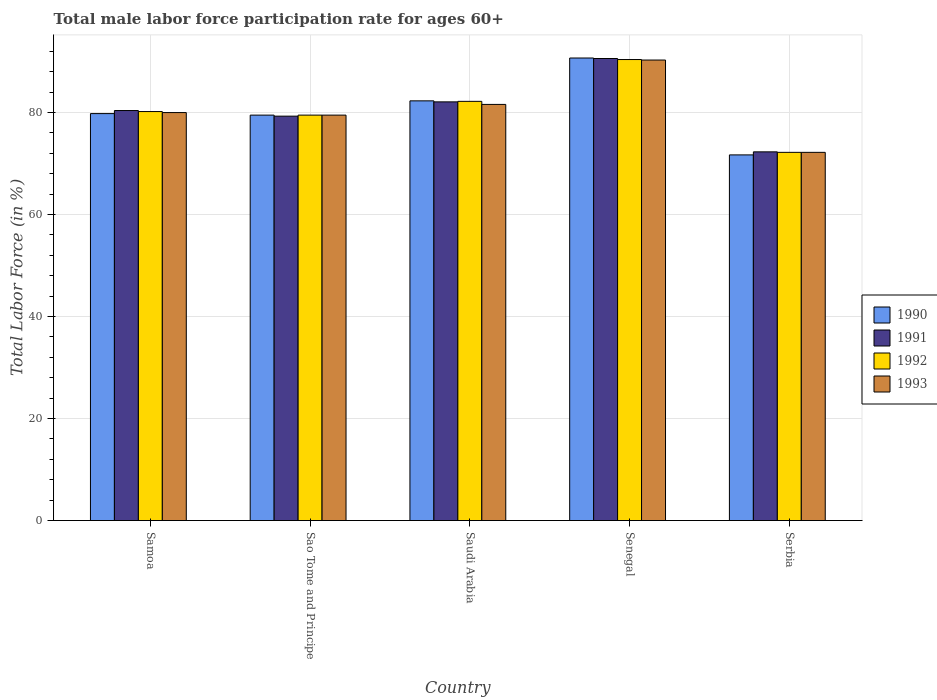How many groups of bars are there?
Ensure brevity in your answer.  5. Are the number of bars per tick equal to the number of legend labels?
Provide a succinct answer. Yes. How many bars are there on the 3rd tick from the left?
Provide a short and direct response. 4. How many bars are there on the 1st tick from the right?
Make the answer very short. 4. What is the label of the 5th group of bars from the left?
Give a very brief answer. Serbia. In how many cases, is the number of bars for a given country not equal to the number of legend labels?
Your response must be concise. 0. What is the male labor force participation rate in 1991 in Sao Tome and Principe?
Give a very brief answer. 79.3. Across all countries, what is the maximum male labor force participation rate in 1991?
Offer a terse response. 90.6. Across all countries, what is the minimum male labor force participation rate in 1992?
Give a very brief answer. 72.2. In which country was the male labor force participation rate in 1993 maximum?
Offer a very short reply. Senegal. In which country was the male labor force participation rate in 1991 minimum?
Your answer should be very brief. Serbia. What is the total male labor force participation rate in 1991 in the graph?
Give a very brief answer. 404.7. What is the difference between the male labor force participation rate in 1992 in Saudi Arabia and that in Senegal?
Offer a terse response. -8.2. What is the difference between the male labor force participation rate in 1993 in Sao Tome and Principe and the male labor force participation rate in 1990 in Senegal?
Keep it short and to the point. -11.2. What is the average male labor force participation rate in 1992 per country?
Keep it short and to the point. 80.9. What is the difference between the male labor force participation rate of/in 1990 and male labor force participation rate of/in 1992 in Samoa?
Provide a short and direct response. -0.4. What is the ratio of the male labor force participation rate in 1990 in Sao Tome and Principe to that in Saudi Arabia?
Offer a very short reply. 0.97. Is the male labor force participation rate in 1990 in Sao Tome and Principe less than that in Serbia?
Give a very brief answer. No. What is the difference between the highest and the second highest male labor force participation rate in 1993?
Your answer should be very brief. -1.6. What is the difference between the highest and the lowest male labor force participation rate in 1991?
Provide a short and direct response. 18.3. In how many countries, is the male labor force participation rate in 1992 greater than the average male labor force participation rate in 1992 taken over all countries?
Give a very brief answer. 2. What does the 4th bar from the left in Serbia represents?
Your answer should be compact. 1993. Is it the case that in every country, the sum of the male labor force participation rate in 1991 and male labor force participation rate in 1990 is greater than the male labor force participation rate in 1993?
Offer a terse response. Yes. How many bars are there?
Make the answer very short. 20. Where does the legend appear in the graph?
Provide a succinct answer. Center right. How are the legend labels stacked?
Give a very brief answer. Vertical. What is the title of the graph?
Your answer should be compact. Total male labor force participation rate for ages 60+. What is the label or title of the X-axis?
Your response must be concise. Country. What is the label or title of the Y-axis?
Ensure brevity in your answer.  Total Labor Force (in %). What is the Total Labor Force (in %) of 1990 in Samoa?
Give a very brief answer. 79.8. What is the Total Labor Force (in %) in 1991 in Samoa?
Your answer should be compact. 80.4. What is the Total Labor Force (in %) of 1992 in Samoa?
Your answer should be compact. 80.2. What is the Total Labor Force (in %) of 1993 in Samoa?
Your response must be concise. 80. What is the Total Labor Force (in %) of 1990 in Sao Tome and Principe?
Your response must be concise. 79.5. What is the Total Labor Force (in %) in 1991 in Sao Tome and Principe?
Make the answer very short. 79.3. What is the Total Labor Force (in %) of 1992 in Sao Tome and Principe?
Provide a succinct answer. 79.5. What is the Total Labor Force (in %) in 1993 in Sao Tome and Principe?
Ensure brevity in your answer.  79.5. What is the Total Labor Force (in %) in 1990 in Saudi Arabia?
Offer a very short reply. 82.3. What is the Total Labor Force (in %) in 1991 in Saudi Arabia?
Provide a succinct answer. 82.1. What is the Total Labor Force (in %) in 1992 in Saudi Arabia?
Your answer should be very brief. 82.2. What is the Total Labor Force (in %) in 1993 in Saudi Arabia?
Keep it short and to the point. 81.6. What is the Total Labor Force (in %) of 1990 in Senegal?
Provide a succinct answer. 90.7. What is the Total Labor Force (in %) of 1991 in Senegal?
Offer a terse response. 90.6. What is the Total Labor Force (in %) of 1992 in Senegal?
Keep it short and to the point. 90.4. What is the Total Labor Force (in %) of 1993 in Senegal?
Ensure brevity in your answer.  90.3. What is the Total Labor Force (in %) of 1990 in Serbia?
Provide a succinct answer. 71.7. What is the Total Labor Force (in %) of 1991 in Serbia?
Offer a terse response. 72.3. What is the Total Labor Force (in %) in 1992 in Serbia?
Ensure brevity in your answer.  72.2. What is the Total Labor Force (in %) of 1993 in Serbia?
Your answer should be compact. 72.2. Across all countries, what is the maximum Total Labor Force (in %) in 1990?
Offer a very short reply. 90.7. Across all countries, what is the maximum Total Labor Force (in %) in 1991?
Keep it short and to the point. 90.6. Across all countries, what is the maximum Total Labor Force (in %) of 1992?
Give a very brief answer. 90.4. Across all countries, what is the maximum Total Labor Force (in %) in 1993?
Provide a short and direct response. 90.3. Across all countries, what is the minimum Total Labor Force (in %) of 1990?
Give a very brief answer. 71.7. Across all countries, what is the minimum Total Labor Force (in %) of 1991?
Your answer should be compact. 72.3. Across all countries, what is the minimum Total Labor Force (in %) in 1992?
Your response must be concise. 72.2. Across all countries, what is the minimum Total Labor Force (in %) in 1993?
Your answer should be compact. 72.2. What is the total Total Labor Force (in %) of 1990 in the graph?
Make the answer very short. 404. What is the total Total Labor Force (in %) of 1991 in the graph?
Ensure brevity in your answer.  404.7. What is the total Total Labor Force (in %) of 1992 in the graph?
Your answer should be compact. 404.5. What is the total Total Labor Force (in %) in 1993 in the graph?
Your response must be concise. 403.6. What is the difference between the Total Labor Force (in %) in 1991 in Samoa and that in Sao Tome and Principe?
Make the answer very short. 1.1. What is the difference between the Total Labor Force (in %) of 1992 in Samoa and that in Sao Tome and Principe?
Provide a succinct answer. 0.7. What is the difference between the Total Labor Force (in %) in 1992 in Samoa and that in Saudi Arabia?
Keep it short and to the point. -2. What is the difference between the Total Labor Force (in %) of 1990 in Samoa and that in Senegal?
Your answer should be compact. -10.9. What is the difference between the Total Labor Force (in %) of 1992 in Samoa and that in Senegal?
Your response must be concise. -10.2. What is the difference between the Total Labor Force (in %) in 1990 in Samoa and that in Serbia?
Your answer should be very brief. 8.1. What is the difference between the Total Labor Force (in %) of 1991 in Samoa and that in Serbia?
Your answer should be very brief. 8.1. What is the difference between the Total Labor Force (in %) in 1992 in Samoa and that in Serbia?
Your answer should be very brief. 8. What is the difference between the Total Labor Force (in %) of 1993 in Samoa and that in Serbia?
Provide a short and direct response. 7.8. What is the difference between the Total Labor Force (in %) of 1990 in Sao Tome and Principe and that in Saudi Arabia?
Give a very brief answer. -2.8. What is the difference between the Total Labor Force (in %) of 1991 in Sao Tome and Principe and that in Senegal?
Your answer should be compact. -11.3. What is the difference between the Total Labor Force (in %) in 1992 in Sao Tome and Principe and that in Senegal?
Ensure brevity in your answer.  -10.9. What is the difference between the Total Labor Force (in %) in 1990 in Sao Tome and Principe and that in Serbia?
Keep it short and to the point. 7.8. What is the difference between the Total Labor Force (in %) of 1991 in Saudi Arabia and that in Senegal?
Ensure brevity in your answer.  -8.5. What is the difference between the Total Labor Force (in %) of 1992 in Saudi Arabia and that in Serbia?
Offer a very short reply. 10. What is the difference between the Total Labor Force (in %) of 1993 in Saudi Arabia and that in Serbia?
Your response must be concise. 9.4. What is the difference between the Total Labor Force (in %) in 1991 in Senegal and that in Serbia?
Make the answer very short. 18.3. What is the difference between the Total Labor Force (in %) of 1993 in Senegal and that in Serbia?
Keep it short and to the point. 18.1. What is the difference between the Total Labor Force (in %) in 1990 in Samoa and the Total Labor Force (in %) in 1991 in Sao Tome and Principe?
Offer a very short reply. 0.5. What is the difference between the Total Labor Force (in %) in 1990 in Samoa and the Total Labor Force (in %) in 1992 in Sao Tome and Principe?
Provide a succinct answer. 0.3. What is the difference between the Total Labor Force (in %) in 1991 in Samoa and the Total Labor Force (in %) in 1992 in Sao Tome and Principe?
Keep it short and to the point. 0.9. What is the difference between the Total Labor Force (in %) in 1992 in Samoa and the Total Labor Force (in %) in 1993 in Sao Tome and Principe?
Offer a very short reply. 0.7. What is the difference between the Total Labor Force (in %) in 1990 in Samoa and the Total Labor Force (in %) in 1991 in Saudi Arabia?
Your response must be concise. -2.3. What is the difference between the Total Labor Force (in %) of 1990 in Samoa and the Total Labor Force (in %) of 1993 in Saudi Arabia?
Give a very brief answer. -1.8. What is the difference between the Total Labor Force (in %) in 1991 in Samoa and the Total Labor Force (in %) in 1992 in Saudi Arabia?
Give a very brief answer. -1.8. What is the difference between the Total Labor Force (in %) in 1990 in Samoa and the Total Labor Force (in %) in 1992 in Senegal?
Your answer should be compact. -10.6. What is the difference between the Total Labor Force (in %) of 1992 in Samoa and the Total Labor Force (in %) of 1993 in Senegal?
Make the answer very short. -10.1. What is the difference between the Total Labor Force (in %) in 1990 in Samoa and the Total Labor Force (in %) in 1991 in Serbia?
Your answer should be very brief. 7.5. What is the difference between the Total Labor Force (in %) in 1990 in Samoa and the Total Labor Force (in %) in 1992 in Serbia?
Offer a very short reply. 7.6. What is the difference between the Total Labor Force (in %) of 1990 in Samoa and the Total Labor Force (in %) of 1993 in Serbia?
Give a very brief answer. 7.6. What is the difference between the Total Labor Force (in %) in 1992 in Samoa and the Total Labor Force (in %) in 1993 in Serbia?
Ensure brevity in your answer.  8. What is the difference between the Total Labor Force (in %) of 1990 in Sao Tome and Principe and the Total Labor Force (in %) of 1991 in Saudi Arabia?
Provide a succinct answer. -2.6. What is the difference between the Total Labor Force (in %) of 1990 in Sao Tome and Principe and the Total Labor Force (in %) of 1992 in Saudi Arabia?
Ensure brevity in your answer.  -2.7. What is the difference between the Total Labor Force (in %) in 1992 in Sao Tome and Principe and the Total Labor Force (in %) in 1993 in Saudi Arabia?
Keep it short and to the point. -2.1. What is the difference between the Total Labor Force (in %) in 1990 in Sao Tome and Principe and the Total Labor Force (in %) in 1993 in Senegal?
Your answer should be compact. -10.8. What is the difference between the Total Labor Force (in %) in 1991 in Sao Tome and Principe and the Total Labor Force (in %) in 1992 in Senegal?
Your response must be concise. -11.1. What is the difference between the Total Labor Force (in %) in 1992 in Sao Tome and Principe and the Total Labor Force (in %) in 1993 in Senegal?
Your response must be concise. -10.8. What is the difference between the Total Labor Force (in %) of 1990 in Sao Tome and Principe and the Total Labor Force (in %) of 1991 in Serbia?
Provide a short and direct response. 7.2. What is the difference between the Total Labor Force (in %) in 1990 in Sao Tome and Principe and the Total Labor Force (in %) in 1993 in Serbia?
Ensure brevity in your answer.  7.3. What is the difference between the Total Labor Force (in %) in 1991 in Sao Tome and Principe and the Total Labor Force (in %) in 1992 in Serbia?
Provide a succinct answer. 7.1. What is the difference between the Total Labor Force (in %) in 1991 in Sao Tome and Principe and the Total Labor Force (in %) in 1993 in Serbia?
Your answer should be compact. 7.1. What is the difference between the Total Labor Force (in %) of 1992 in Sao Tome and Principe and the Total Labor Force (in %) of 1993 in Serbia?
Give a very brief answer. 7.3. What is the difference between the Total Labor Force (in %) of 1990 in Saudi Arabia and the Total Labor Force (in %) of 1991 in Senegal?
Your response must be concise. -8.3. What is the difference between the Total Labor Force (in %) in 1990 in Saudi Arabia and the Total Labor Force (in %) in 1992 in Senegal?
Provide a succinct answer. -8.1. What is the difference between the Total Labor Force (in %) of 1990 in Saudi Arabia and the Total Labor Force (in %) of 1993 in Senegal?
Provide a succinct answer. -8. What is the difference between the Total Labor Force (in %) of 1991 in Saudi Arabia and the Total Labor Force (in %) of 1993 in Senegal?
Your answer should be compact. -8.2. What is the difference between the Total Labor Force (in %) in 1992 in Saudi Arabia and the Total Labor Force (in %) in 1993 in Senegal?
Ensure brevity in your answer.  -8.1. What is the difference between the Total Labor Force (in %) in 1990 in Saudi Arabia and the Total Labor Force (in %) in 1991 in Serbia?
Your answer should be compact. 10. What is the difference between the Total Labor Force (in %) in 1990 in Saudi Arabia and the Total Labor Force (in %) in 1992 in Serbia?
Ensure brevity in your answer.  10.1. What is the difference between the Total Labor Force (in %) of 1990 in Saudi Arabia and the Total Labor Force (in %) of 1993 in Serbia?
Offer a terse response. 10.1. What is the difference between the Total Labor Force (in %) in 1991 in Saudi Arabia and the Total Labor Force (in %) in 1992 in Serbia?
Ensure brevity in your answer.  9.9. What is the difference between the Total Labor Force (in %) in 1991 in Saudi Arabia and the Total Labor Force (in %) in 1993 in Serbia?
Give a very brief answer. 9.9. What is the difference between the Total Labor Force (in %) in 1990 in Senegal and the Total Labor Force (in %) in 1991 in Serbia?
Your answer should be compact. 18.4. What is the difference between the Total Labor Force (in %) in 1991 in Senegal and the Total Labor Force (in %) in 1992 in Serbia?
Give a very brief answer. 18.4. What is the difference between the Total Labor Force (in %) of 1992 in Senegal and the Total Labor Force (in %) of 1993 in Serbia?
Your answer should be compact. 18.2. What is the average Total Labor Force (in %) in 1990 per country?
Your answer should be very brief. 80.8. What is the average Total Labor Force (in %) in 1991 per country?
Give a very brief answer. 80.94. What is the average Total Labor Force (in %) in 1992 per country?
Make the answer very short. 80.9. What is the average Total Labor Force (in %) in 1993 per country?
Offer a very short reply. 80.72. What is the difference between the Total Labor Force (in %) in 1992 and Total Labor Force (in %) in 1993 in Samoa?
Your answer should be very brief. 0.2. What is the difference between the Total Labor Force (in %) in 1990 and Total Labor Force (in %) in 1993 in Sao Tome and Principe?
Provide a succinct answer. 0. What is the difference between the Total Labor Force (in %) in 1991 and Total Labor Force (in %) in 1992 in Sao Tome and Principe?
Keep it short and to the point. -0.2. What is the difference between the Total Labor Force (in %) of 1992 and Total Labor Force (in %) of 1993 in Sao Tome and Principe?
Keep it short and to the point. 0. What is the difference between the Total Labor Force (in %) in 1990 and Total Labor Force (in %) in 1992 in Saudi Arabia?
Provide a succinct answer. 0.1. What is the difference between the Total Labor Force (in %) in 1990 and Total Labor Force (in %) in 1993 in Saudi Arabia?
Ensure brevity in your answer.  0.7. What is the difference between the Total Labor Force (in %) of 1991 and Total Labor Force (in %) of 1992 in Saudi Arabia?
Ensure brevity in your answer.  -0.1. What is the difference between the Total Labor Force (in %) of 1991 and Total Labor Force (in %) of 1993 in Saudi Arabia?
Provide a short and direct response. 0.5. What is the difference between the Total Labor Force (in %) of 1990 and Total Labor Force (in %) of 1991 in Senegal?
Ensure brevity in your answer.  0.1. What is the difference between the Total Labor Force (in %) of 1990 and Total Labor Force (in %) of 1993 in Senegal?
Your answer should be very brief. 0.4. What is the difference between the Total Labor Force (in %) of 1991 and Total Labor Force (in %) of 1992 in Senegal?
Offer a very short reply. 0.2. What is the difference between the Total Labor Force (in %) of 1991 and Total Labor Force (in %) of 1993 in Senegal?
Offer a very short reply. 0.3. What is the difference between the Total Labor Force (in %) of 1992 and Total Labor Force (in %) of 1993 in Senegal?
Your response must be concise. 0.1. What is the difference between the Total Labor Force (in %) in 1990 and Total Labor Force (in %) in 1991 in Serbia?
Offer a very short reply. -0.6. What is the difference between the Total Labor Force (in %) of 1991 and Total Labor Force (in %) of 1992 in Serbia?
Give a very brief answer. 0.1. What is the difference between the Total Labor Force (in %) in 1991 and Total Labor Force (in %) in 1993 in Serbia?
Keep it short and to the point. 0.1. What is the difference between the Total Labor Force (in %) of 1992 and Total Labor Force (in %) of 1993 in Serbia?
Make the answer very short. 0. What is the ratio of the Total Labor Force (in %) in 1991 in Samoa to that in Sao Tome and Principe?
Your answer should be compact. 1.01. What is the ratio of the Total Labor Force (in %) in 1992 in Samoa to that in Sao Tome and Principe?
Make the answer very short. 1.01. What is the ratio of the Total Labor Force (in %) in 1993 in Samoa to that in Sao Tome and Principe?
Give a very brief answer. 1.01. What is the ratio of the Total Labor Force (in %) in 1990 in Samoa to that in Saudi Arabia?
Keep it short and to the point. 0.97. What is the ratio of the Total Labor Force (in %) in 1991 in Samoa to that in Saudi Arabia?
Your answer should be compact. 0.98. What is the ratio of the Total Labor Force (in %) in 1992 in Samoa to that in Saudi Arabia?
Provide a short and direct response. 0.98. What is the ratio of the Total Labor Force (in %) in 1993 in Samoa to that in Saudi Arabia?
Keep it short and to the point. 0.98. What is the ratio of the Total Labor Force (in %) in 1990 in Samoa to that in Senegal?
Your response must be concise. 0.88. What is the ratio of the Total Labor Force (in %) of 1991 in Samoa to that in Senegal?
Give a very brief answer. 0.89. What is the ratio of the Total Labor Force (in %) of 1992 in Samoa to that in Senegal?
Offer a very short reply. 0.89. What is the ratio of the Total Labor Force (in %) in 1993 in Samoa to that in Senegal?
Provide a short and direct response. 0.89. What is the ratio of the Total Labor Force (in %) in 1990 in Samoa to that in Serbia?
Keep it short and to the point. 1.11. What is the ratio of the Total Labor Force (in %) of 1991 in Samoa to that in Serbia?
Your response must be concise. 1.11. What is the ratio of the Total Labor Force (in %) of 1992 in Samoa to that in Serbia?
Your answer should be very brief. 1.11. What is the ratio of the Total Labor Force (in %) of 1993 in Samoa to that in Serbia?
Give a very brief answer. 1.11. What is the ratio of the Total Labor Force (in %) in 1990 in Sao Tome and Principe to that in Saudi Arabia?
Ensure brevity in your answer.  0.97. What is the ratio of the Total Labor Force (in %) of 1991 in Sao Tome and Principe to that in Saudi Arabia?
Provide a succinct answer. 0.97. What is the ratio of the Total Labor Force (in %) in 1992 in Sao Tome and Principe to that in Saudi Arabia?
Provide a short and direct response. 0.97. What is the ratio of the Total Labor Force (in %) of 1993 in Sao Tome and Principe to that in Saudi Arabia?
Your response must be concise. 0.97. What is the ratio of the Total Labor Force (in %) in 1990 in Sao Tome and Principe to that in Senegal?
Make the answer very short. 0.88. What is the ratio of the Total Labor Force (in %) in 1991 in Sao Tome and Principe to that in Senegal?
Ensure brevity in your answer.  0.88. What is the ratio of the Total Labor Force (in %) of 1992 in Sao Tome and Principe to that in Senegal?
Offer a very short reply. 0.88. What is the ratio of the Total Labor Force (in %) of 1993 in Sao Tome and Principe to that in Senegal?
Offer a terse response. 0.88. What is the ratio of the Total Labor Force (in %) of 1990 in Sao Tome and Principe to that in Serbia?
Give a very brief answer. 1.11. What is the ratio of the Total Labor Force (in %) of 1991 in Sao Tome and Principe to that in Serbia?
Your answer should be very brief. 1.1. What is the ratio of the Total Labor Force (in %) in 1992 in Sao Tome and Principe to that in Serbia?
Your answer should be very brief. 1.1. What is the ratio of the Total Labor Force (in %) of 1993 in Sao Tome and Principe to that in Serbia?
Keep it short and to the point. 1.1. What is the ratio of the Total Labor Force (in %) in 1990 in Saudi Arabia to that in Senegal?
Provide a succinct answer. 0.91. What is the ratio of the Total Labor Force (in %) in 1991 in Saudi Arabia to that in Senegal?
Give a very brief answer. 0.91. What is the ratio of the Total Labor Force (in %) in 1992 in Saudi Arabia to that in Senegal?
Offer a terse response. 0.91. What is the ratio of the Total Labor Force (in %) in 1993 in Saudi Arabia to that in Senegal?
Your response must be concise. 0.9. What is the ratio of the Total Labor Force (in %) of 1990 in Saudi Arabia to that in Serbia?
Make the answer very short. 1.15. What is the ratio of the Total Labor Force (in %) of 1991 in Saudi Arabia to that in Serbia?
Give a very brief answer. 1.14. What is the ratio of the Total Labor Force (in %) in 1992 in Saudi Arabia to that in Serbia?
Offer a very short reply. 1.14. What is the ratio of the Total Labor Force (in %) in 1993 in Saudi Arabia to that in Serbia?
Your response must be concise. 1.13. What is the ratio of the Total Labor Force (in %) of 1990 in Senegal to that in Serbia?
Offer a very short reply. 1.26. What is the ratio of the Total Labor Force (in %) in 1991 in Senegal to that in Serbia?
Offer a very short reply. 1.25. What is the ratio of the Total Labor Force (in %) in 1992 in Senegal to that in Serbia?
Offer a terse response. 1.25. What is the ratio of the Total Labor Force (in %) in 1993 in Senegal to that in Serbia?
Your answer should be very brief. 1.25. What is the difference between the highest and the second highest Total Labor Force (in %) in 1990?
Your answer should be compact. 8.4. What is the difference between the highest and the second highest Total Labor Force (in %) in 1992?
Provide a short and direct response. 8.2. What is the difference between the highest and the lowest Total Labor Force (in %) of 1990?
Keep it short and to the point. 19. What is the difference between the highest and the lowest Total Labor Force (in %) in 1991?
Keep it short and to the point. 18.3. What is the difference between the highest and the lowest Total Labor Force (in %) in 1992?
Your answer should be compact. 18.2. What is the difference between the highest and the lowest Total Labor Force (in %) in 1993?
Make the answer very short. 18.1. 